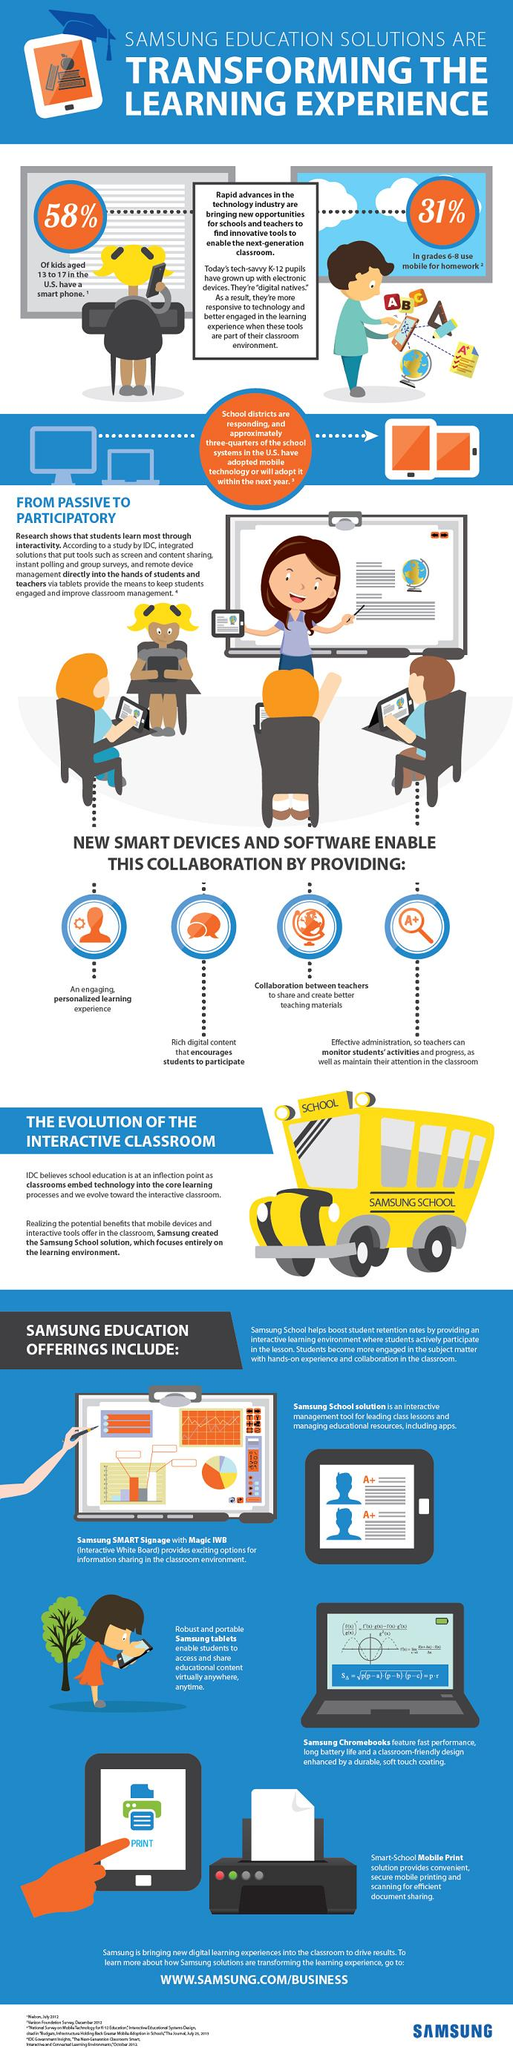Give some essential details in this illustration. According to recent studies, approximately 58% of children aged 13 to 17 in the United States own a smartphone. A recent study has revealed that 31% of students in grades 6-8 in the United States use mobile devices for their homework. 